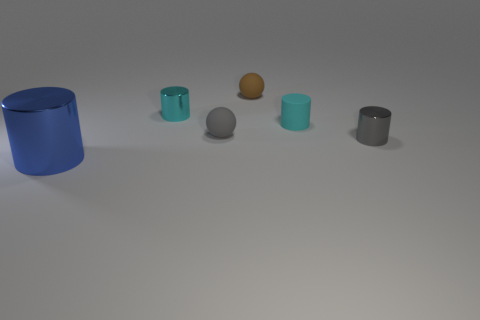Is there another blue shiny object of the same shape as the blue object? no 